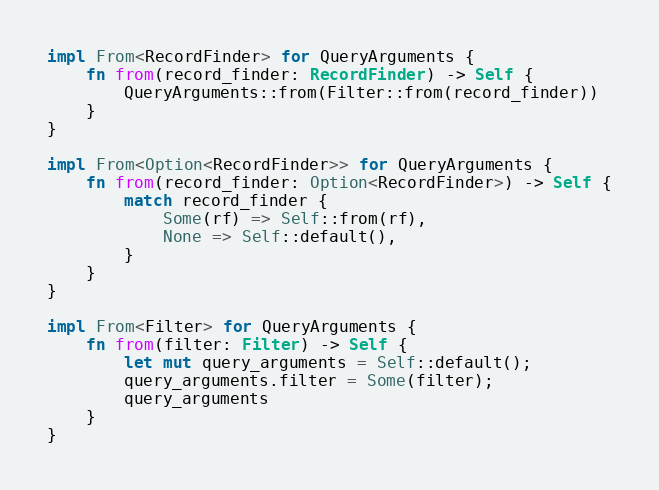<code> <loc_0><loc_0><loc_500><loc_500><_Rust_>
impl From<RecordFinder> for QueryArguments {
    fn from(record_finder: RecordFinder) -> Self {
        QueryArguments::from(Filter::from(record_finder))
    }
}

impl From<Option<RecordFinder>> for QueryArguments {
    fn from(record_finder: Option<RecordFinder>) -> Self {
        match record_finder {
            Some(rf) => Self::from(rf),
            None => Self::default(),
        }
    }
}

impl From<Filter> for QueryArguments {
    fn from(filter: Filter) -> Self {
        let mut query_arguments = Self::default();
        query_arguments.filter = Some(filter);
        query_arguments
    }
}
</code> 